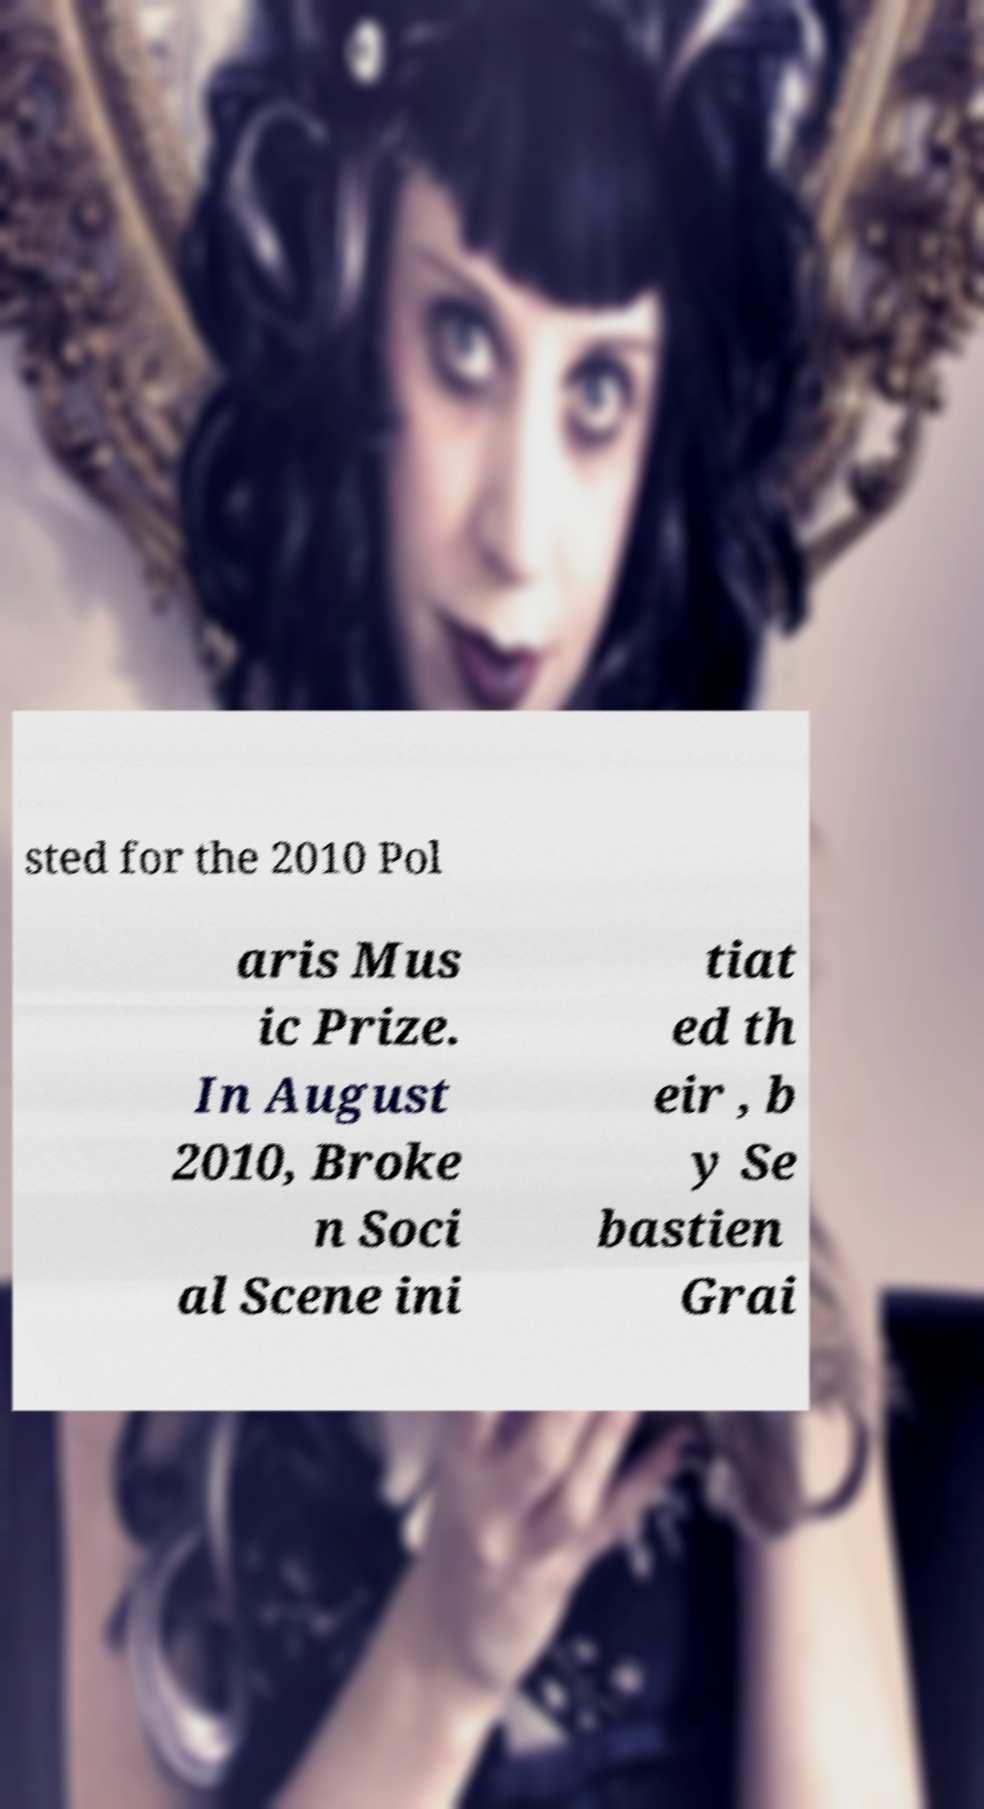Could you assist in decoding the text presented in this image and type it out clearly? sted for the 2010 Pol aris Mus ic Prize. In August 2010, Broke n Soci al Scene ini tiat ed th eir , b y Se bastien Grai 